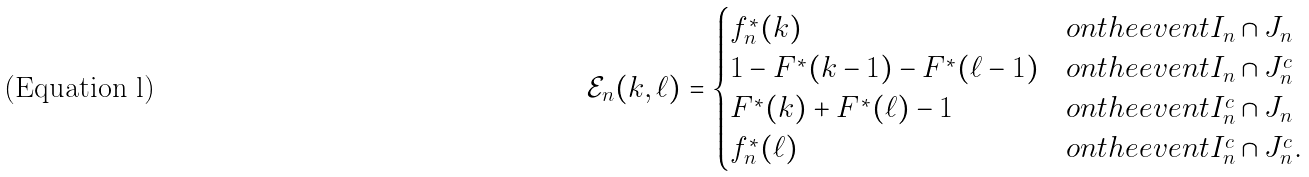<formula> <loc_0><loc_0><loc_500><loc_500>\mathcal { E } _ { n } ( k , \ell ) = \begin{cases} f _ { n } ^ { \ast } ( k ) & o n t h e e v e n t I _ { n } \cap J _ { n } \\ 1 - F ^ { \ast } ( k - 1 ) - F ^ { \ast } ( \ell - 1 ) & o n t h e e v e n t I _ { n } \cap J _ { n } ^ { c } \\ F ^ { \ast } ( k ) + F ^ { \ast } ( \ell ) - 1 & o n t h e e v e n t I _ { n } ^ { c } \cap J _ { n } \\ f _ { n } ^ { \ast } ( \ell ) & o n t h e e v e n t I _ { n } ^ { c } \cap J _ { n } ^ { c } . \end{cases}</formula> 